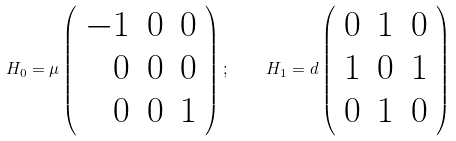Convert formula to latex. <formula><loc_0><loc_0><loc_500><loc_500>H _ { 0 } = \mu \left ( \begin{array} { r r r } - 1 & 0 & 0 \\ 0 & 0 & 0 \\ 0 & 0 & 1 \end{array} \right ) ; \quad H _ { 1 } = d \left ( \begin{array} { r r r } 0 & 1 & 0 \\ 1 & 0 & 1 \\ 0 & 1 & 0 \end{array} \right )</formula> 